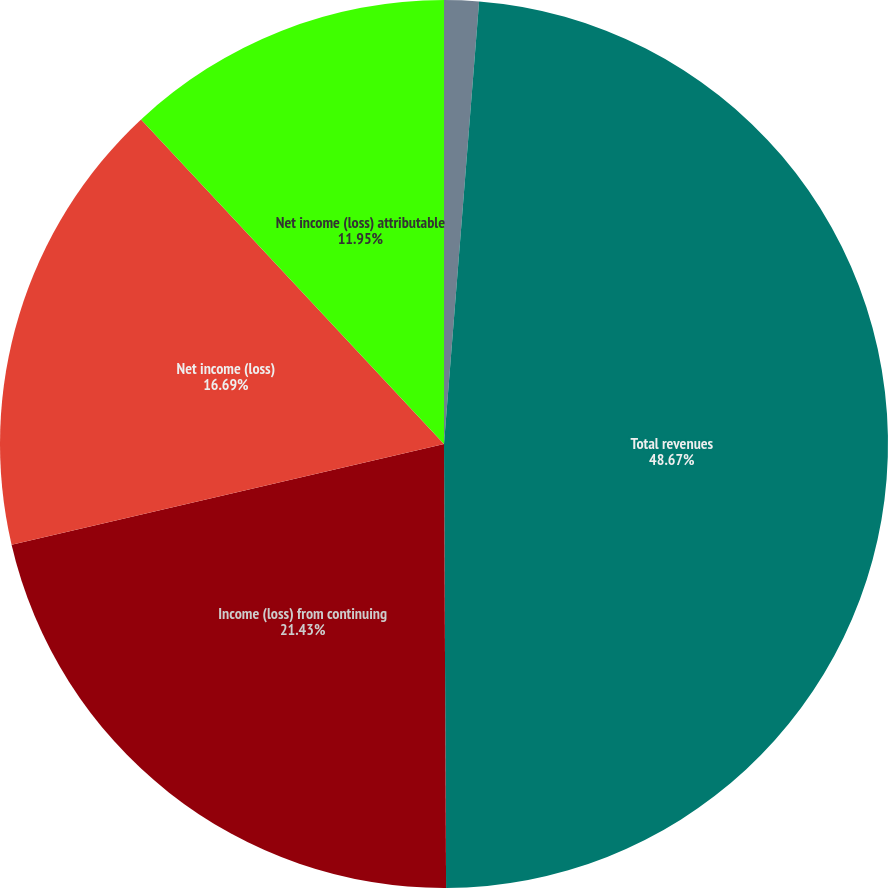Convert chart to OTSL. <chart><loc_0><loc_0><loc_500><loc_500><pie_chart><fcel>Years Ended December 31 (in<fcel>Total revenues<fcel>Income (loss) from continuing<fcel>Net income (loss)<fcel>Net income (loss) attributable<nl><fcel>1.26%<fcel>48.66%<fcel>21.43%<fcel>16.69%<fcel>11.95%<nl></chart> 